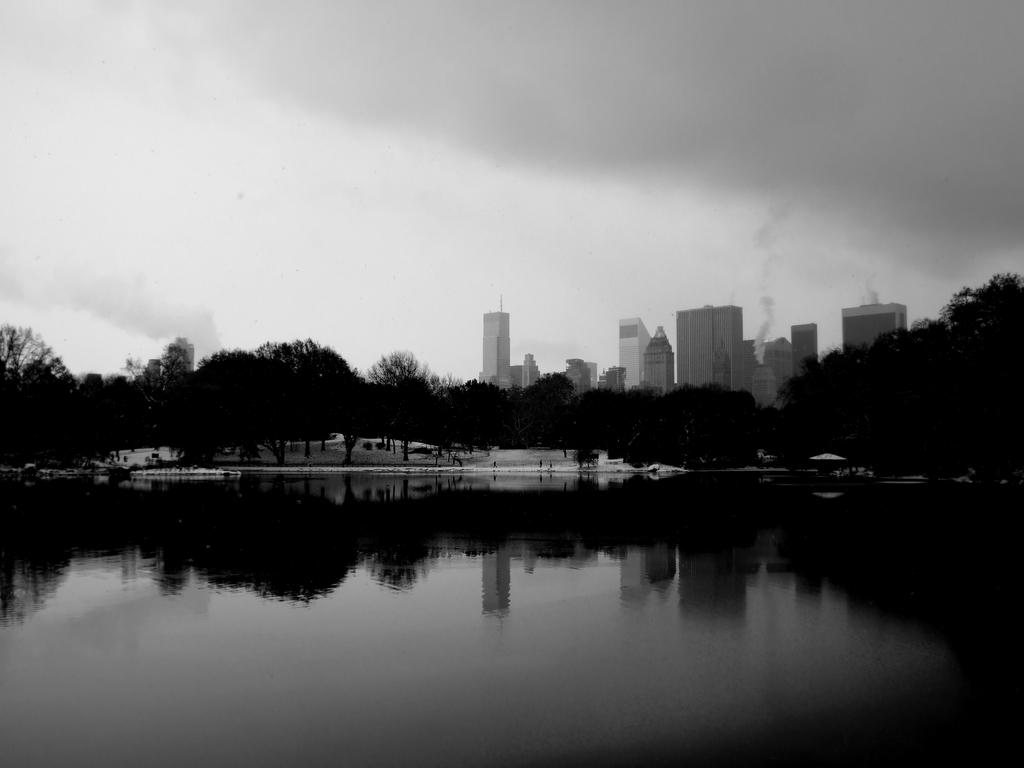What is the color scheme of the image? The image is black and white. What natural element can be seen in the image? There is water visible in the image. What type of vegetation is in the background of the image? There are trees in the background of the image. What type of structures are in the background of the image? There are buildings in the background of the image. What is happening with the buildings in the image? Smoke is coming from the buildings. What part of the natural environment is visible in the image? The sky is visible in the image. Reasoning: Let's think step by following the guidelines to produce the conversation. We start by identifying the color scheme of the image, which is black and white. Then, we describe the natural elements and vegetation present in the image, such as water and trees. Next, we mention the structures in the background, which are buildings, and describe their condition, i.e., smoke coming from them. Finally, we acknowledge the presence of the sky in the image. Absurd Question/Answer: Can you see any boats in the water in the image? There are no boats visible in the water in the image. Is there a cat sitting on the stove in the image? There is no stove or cat present in the image. Can you see any boats in the water in the image? There are no boats visible in the water in the image. Is there a cat sitting on the stove in the image? There is no stove or cat present in the image. 